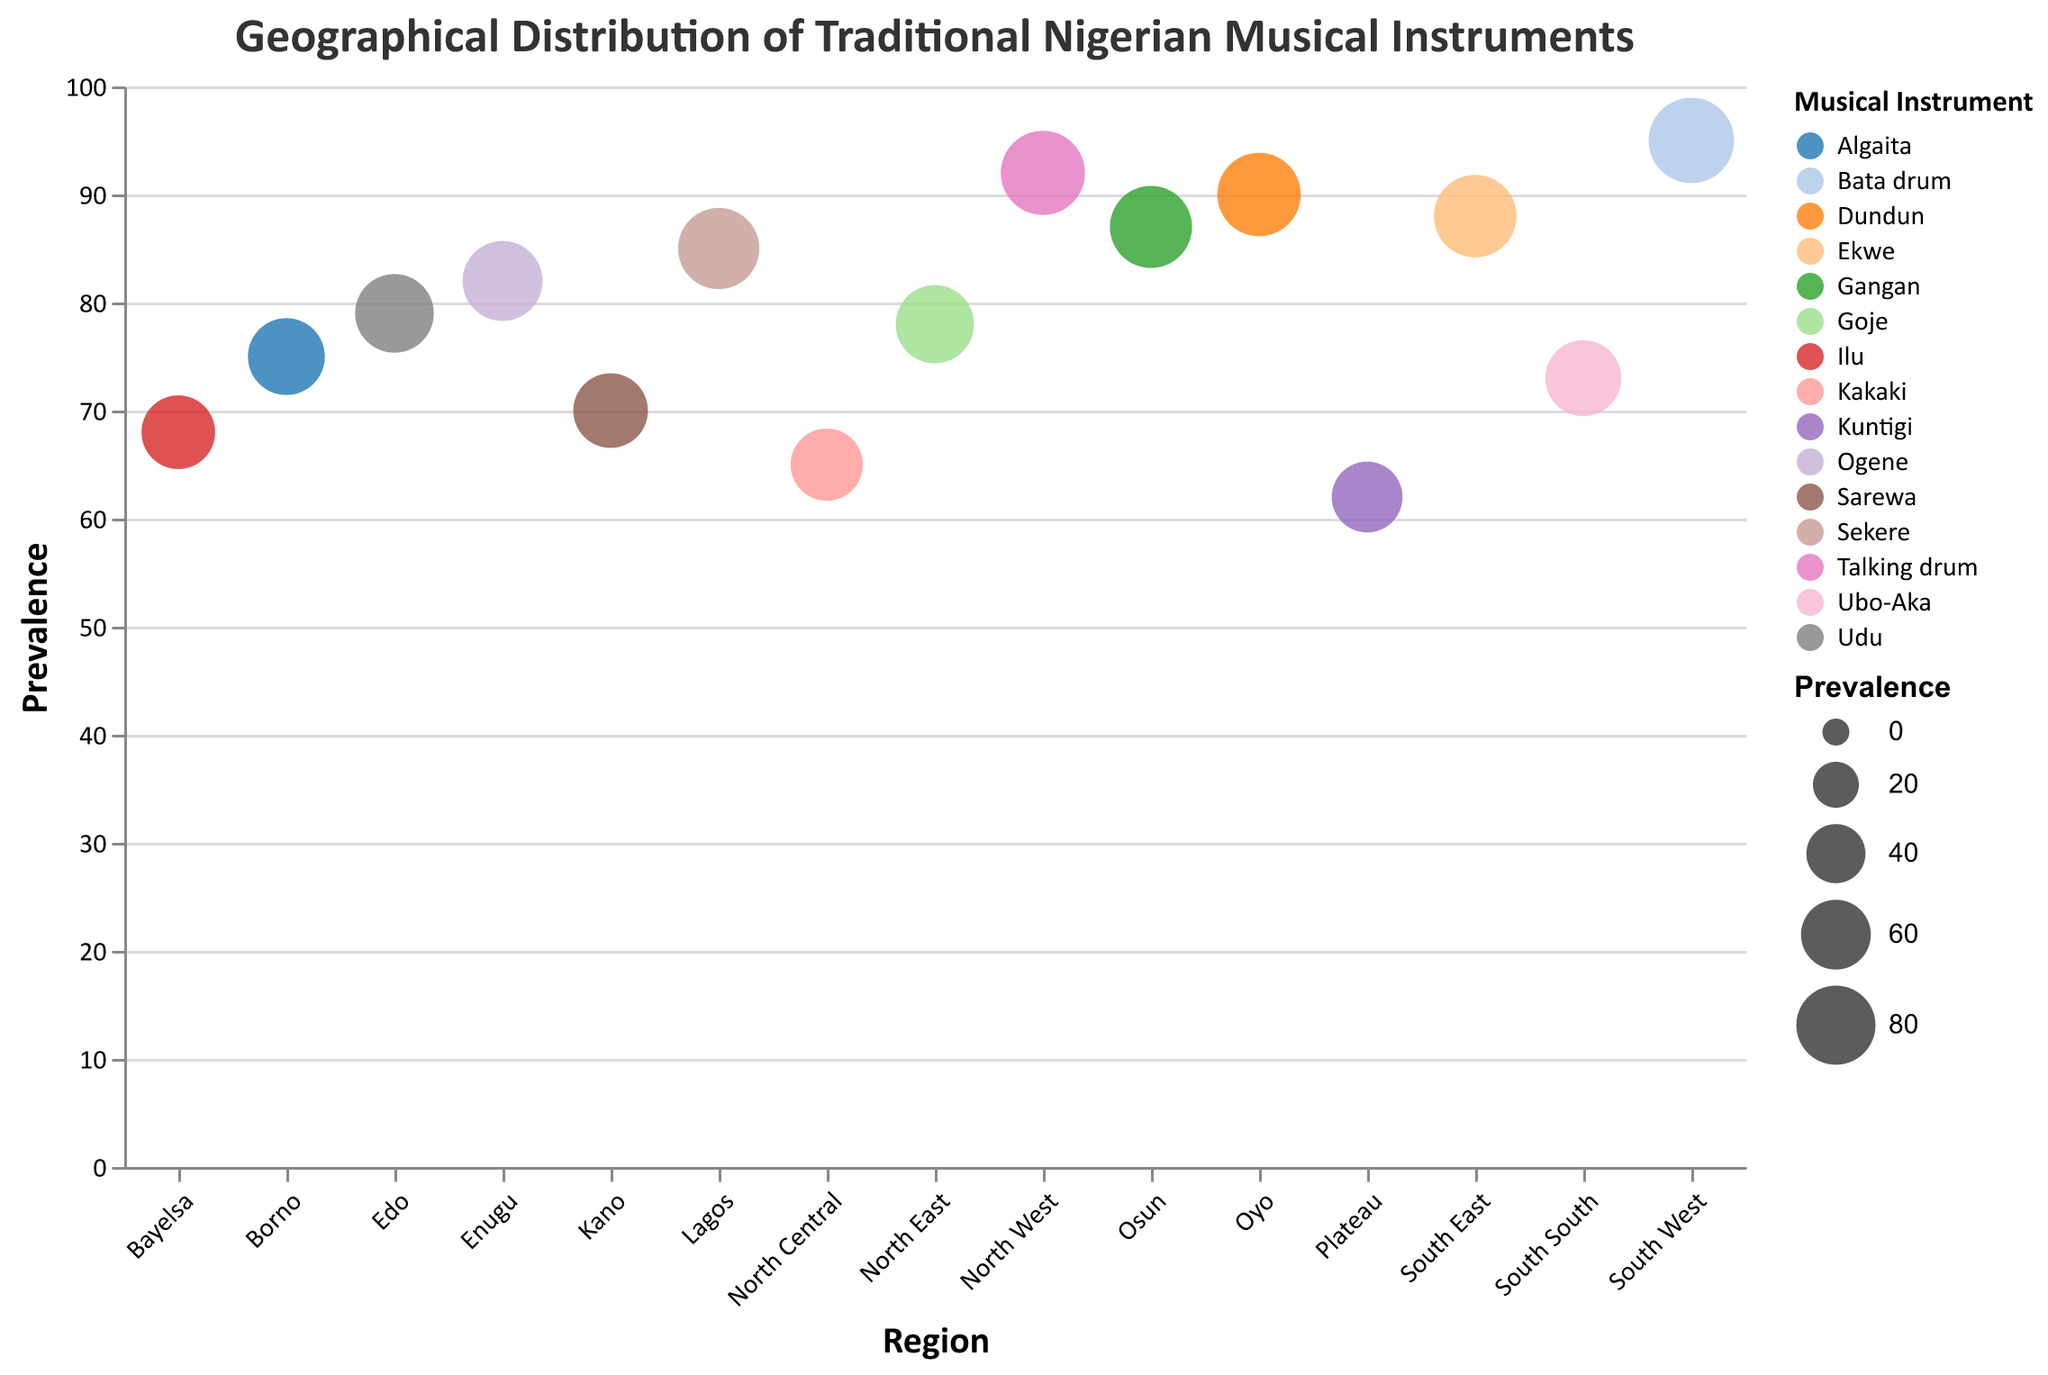What is the title of the figure? The title is located at the top of the figure and reads "Geographical Distribution of Traditional Nigerian Musical Instruments".
Answer: Geographical Distribution of Traditional Nigerian Musical Instruments Which region has the highest prevalence of traditional musical instruments? By looking at the vertical axis and identifying the region with the largest circle closest to the top, we see that "South West" has the highest prevalence at 95 for the Bata drum.
Answer: South West What are the instruments with a prevalence of over 80 in the plotted data? Visual inspection can identify the circles positioned above the 80-mark on the y-axis, showing: Talking drum (North West), Ekwe (South East), Bata drum (South West), Sekere (Lagos), Dundun (Oyo), Ogene (Enugu), and Gangan (Osun).
Answer: Talking drum, Ekwe, Bata drum, Sekere, Dundun, Ogene, Gangan Compare the prevalence of instruments in Lagos and Kano. Which one is higher and by how much? Refer to the two points on the graph labeled "Lagos" and "Kano". Lagos has a prevalence of 85 for Sekere, and Kano has 70 for Sarewa. Subtracting the two values, 85 - 70, we find Lagos is higher by 15.
Answer: Lagos is higher by 15 On average, how prevalent are the traditional musical instruments in the North-central regions (North Central, North East, North West)? Sum the prevalences for Kakaki (65), Goje (78), and Talking drum (92) and divide by 3. (65 + 78 + 92) / 3 = 235 / 3.
Answer: 78.33 Which instrument is the least prevalent and in which region is it found? Identifying the smallest circle on the graph, we find "Kuntigi" with a prevalence of 62 in Plateau.
Answer: Kuntigi in Plateau How does the prevalence of the Ekwe in the South East compare to the Ogene in Enugu? Find the points for "Ekwe" in "South East" and "Ogene" in "Enugu". Ekwe has a prevalence of 88, and Ogene has 82. By comparing, Ekwe has a higher prevalence by 6.
Answer: Ekwe is higher by 6 What is the total prevalence of instruments in the Southern regions (South East, South South, South West)? Sum the prevalences for Ekwe (88), Ubo-Aka (73), and Bata drum (95). 88 + 73 + 95 = 256.
Answer: 256 Which regions have a prevalence of traditional musical instruments above the average prevalence of all instruments in the plot? Calculate the average prevalence: (65 + 78 + 92 + 88 + 73 + 95 + 85 + 70 + 90 + 82 + 68 + 75 + 62 + 79 + 87) / 15 = 79.6. Then identify regions with values above 79.6: North West, South East, South West, Lagos, Oyo, Enugu, Osun, Edo.
Answer: North West, South East, South West, Lagos, Oyo, Enugu, Osun, Edo 